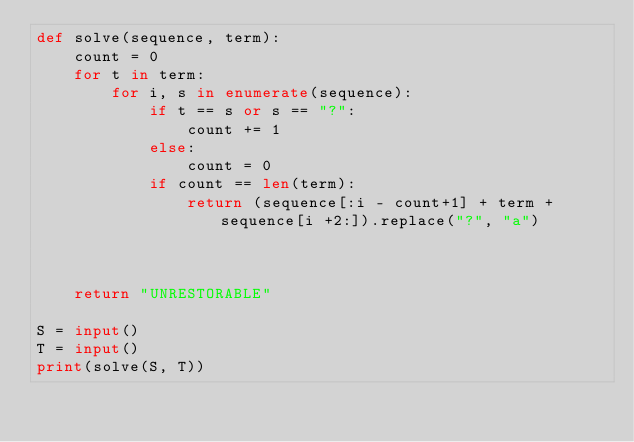Convert code to text. <code><loc_0><loc_0><loc_500><loc_500><_Python_>def solve(sequence, term):
    count = 0
    for t in term:
        for i, s in enumerate(sequence):
            if t == s or s == "?":
                count += 1
            else:
                count = 0
            if count == len(term):
                return (sequence[:i - count+1] + term + sequence[i +2:]).replace("?", "a")
            
            
        
    return "UNRESTORABLE"

S = input()
T = input()
print(solve(S, T))</code> 